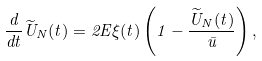<formula> <loc_0><loc_0><loc_500><loc_500>\frac { d } { d t } \widetilde { U } _ { N } ( t ) = 2 E \xi ( t ) \left ( 1 - \frac { \widetilde { U } _ { N } ( t ) } { \bar { u } } \right ) ,</formula> 